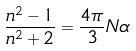<formula> <loc_0><loc_0><loc_500><loc_500>\frac { n ^ { 2 } - 1 } { n ^ { 2 } + 2 } = \frac { 4 \pi } { 3 } N \alpha</formula> 